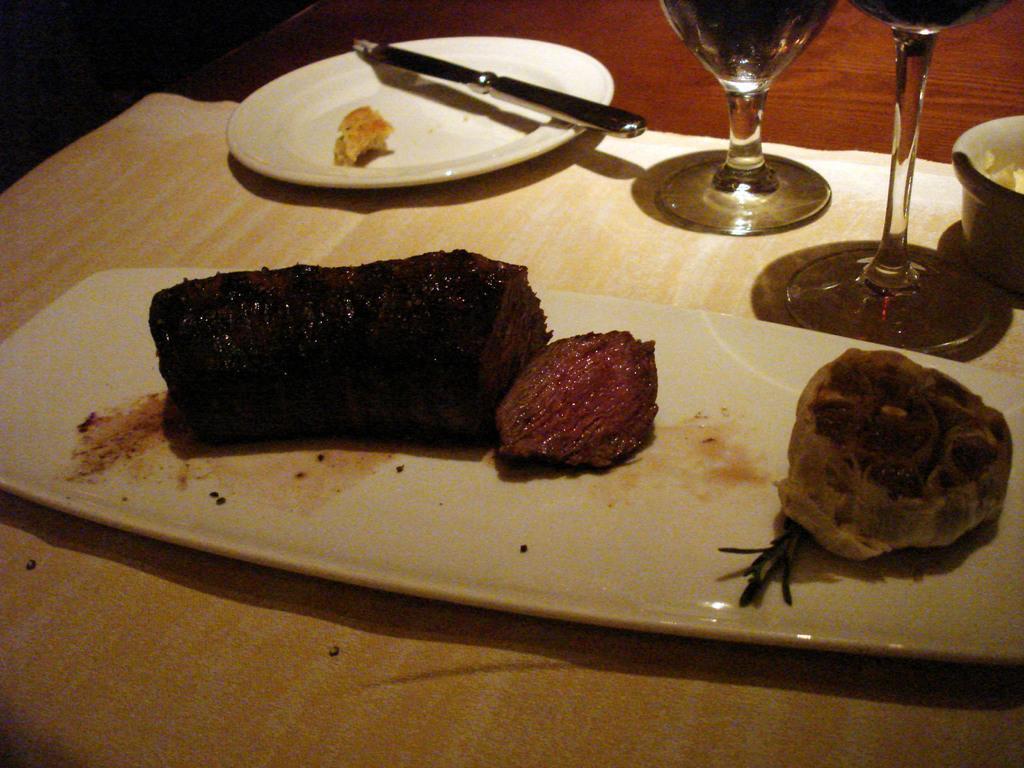In one or two sentences, can you explain what this image depicts? This image is clicked in a room. At the bottom, there is a table on which there are plates along with glasses. In the front, there is flesh kept in a plate. And there is a knife in the plate. At the bottom, there is a floor. 